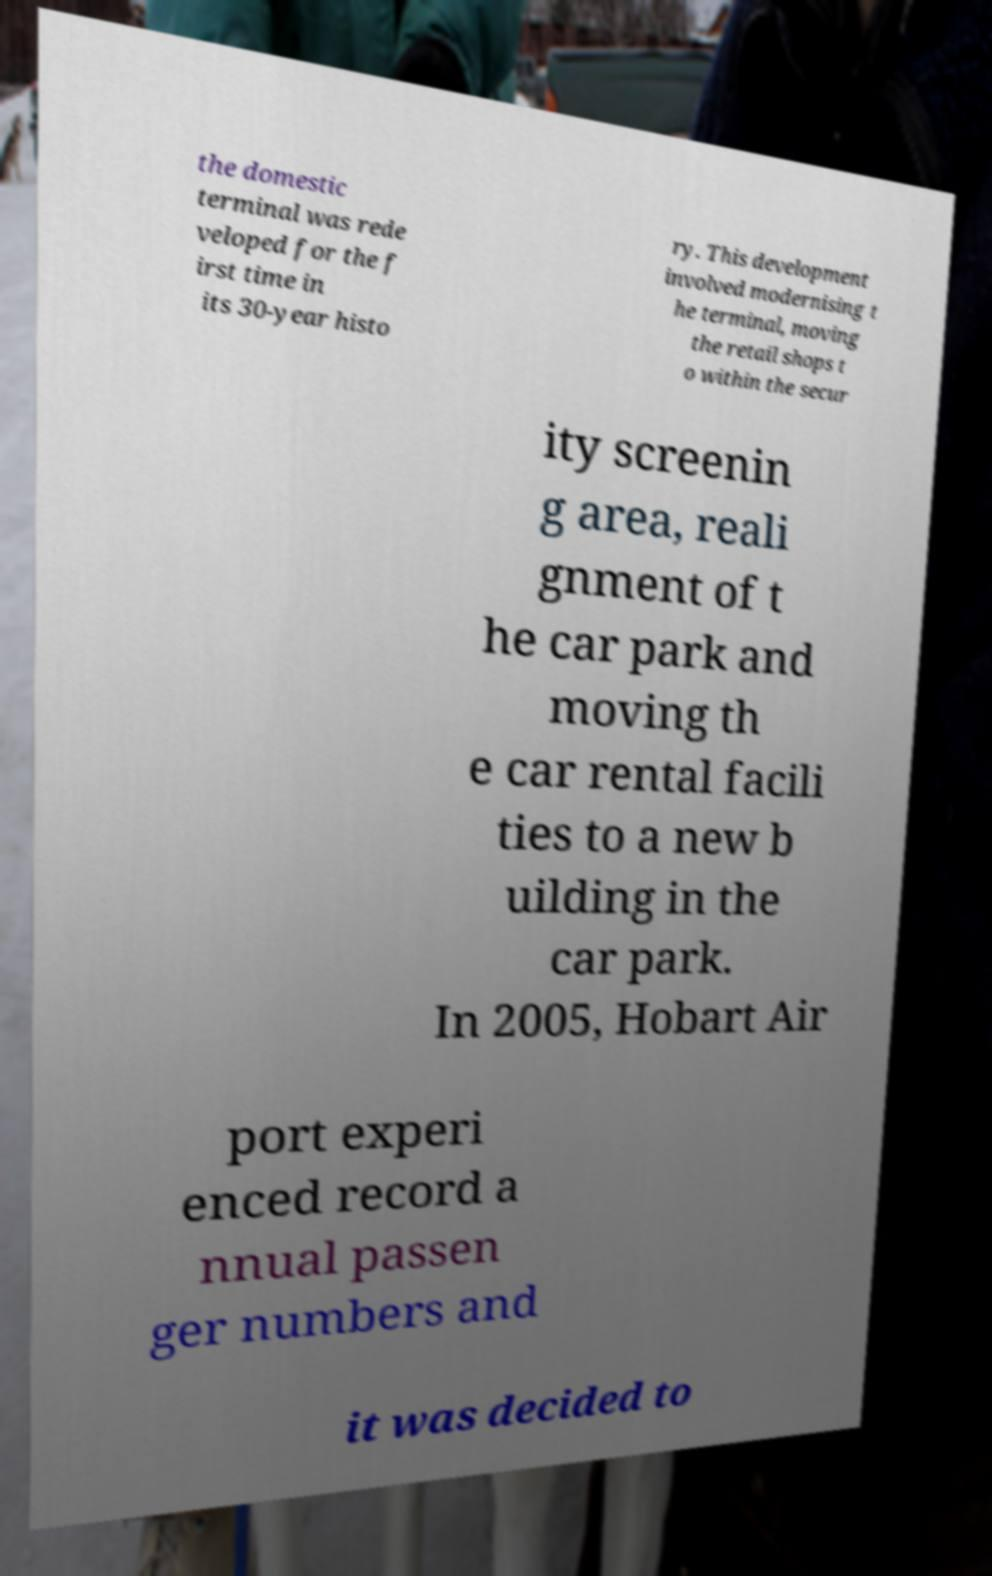There's text embedded in this image that I need extracted. Can you transcribe it verbatim? the domestic terminal was rede veloped for the f irst time in its 30-year histo ry. This development involved modernising t he terminal, moving the retail shops t o within the secur ity screenin g area, reali gnment of t he car park and moving th e car rental facili ties to a new b uilding in the car park. In 2005, Hobart Air port experi enced record a nnual passen ger numbers and it was decided to 